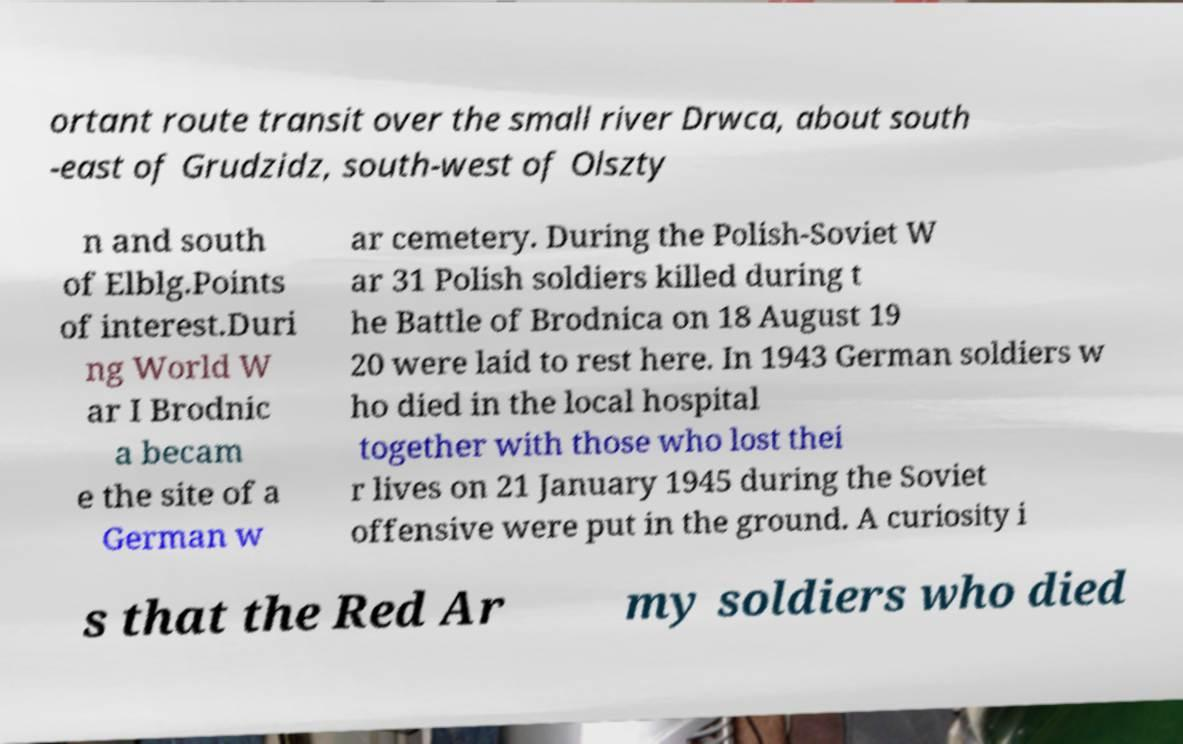For documentation purposes, I need the text within this image transcribed. Could you provide that? ortant route transit over the small river Drwca, about south -east of Grudzidz, south-west of Olszty n and south of Elblg.Points of interest.Duri ng World W ar I Brodnic a becam e the site of a German w ar cemetery. During the Polish-Soviet W ar 31 Polish soldiers killed during t he Battle of Brodnica on 18 August 19 20 were laid to rest here. In 1943 German soldiers w ho died in the local hospital together with those who lost thei r lives on 21 January 1945 during the Soviet offensive were put in the ground. A curiosity i s that the Red Ar my soldiers who died 